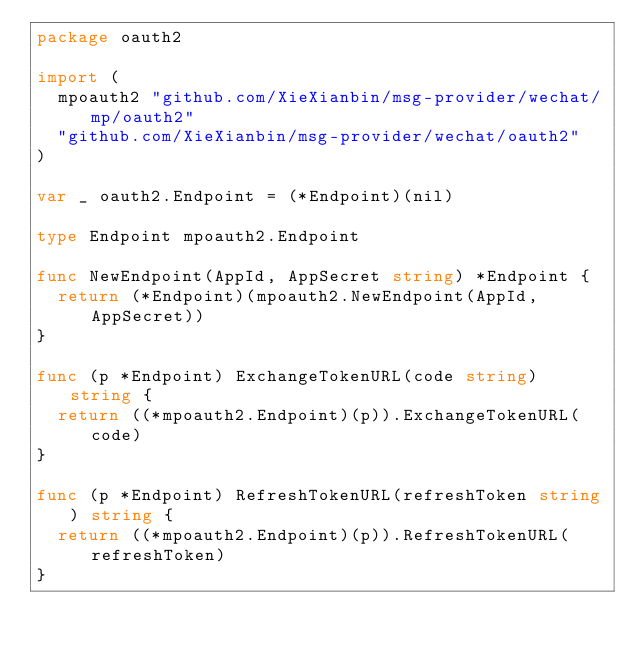<code> <loc_0><loc_0><loc_500><loc_500><_Go_>package oauth2

import (
	mpoauth2 "github.com/XieXianbin/msg-provider/wechat/mp/oauth2"
	"github.com/XieXianbin/msg-provider/wechat/oauth2"
)

var _ oauth2.Endpoint = (*Endpoint)(nil)

type Endpoint mpoauth2.Endpoint

func NewEndpoint(AppId, AppSecret string) *Endpoint {
	return (*Endpoint)(mpoauth2.NewEndpoint(AppId, AppSecret))
}

func (p *Endpoint) ExchangeTokenURL(code string) string {
	return ((*mpoauth2.Endpoint)(p)).ExchangeTokenURL(code)
}

func (p *Endpoint) RefreshTokenURL(refreshToken string) string {
	return ((*mpoauth2.Endpoint)(p)).RefreshTokenURL(refreshToken)
}
</code> 